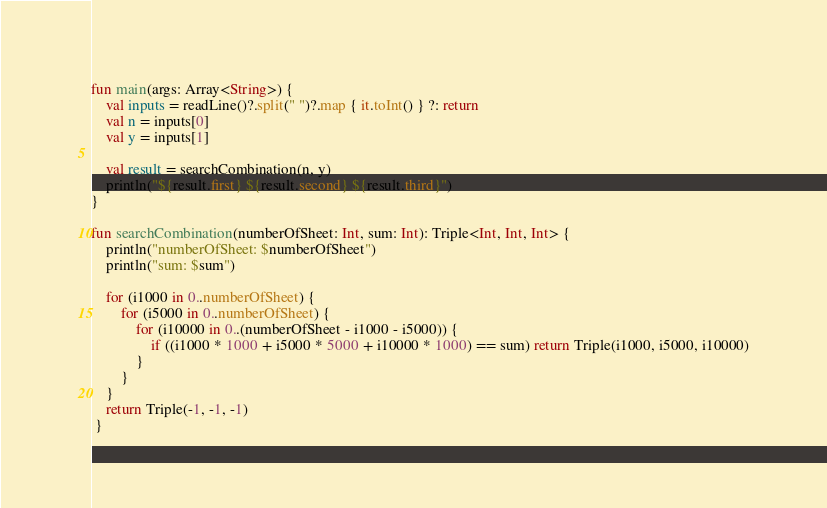Convert code to text. <code><loc_0><loc_0><loc_500><loc_500><_Kotlin_>fun main(args: Array<String>) {
    val inputs = readLine()?.split(" ")?.map { it.toInt() } ?: return
    val n = inputs[0]
    val y = inputs[1]

    val result = searchCombination(n, y)
    println("${result.first} ${result.second} ${result.third}")
}

fun searchCombination(numberOfSheet: Int, sum: Int): Triple<Int, Int, Int> {
    println("numberOfSheet: $numberOfSheet")
    println("sum: $sum")

    for (i1000 in 0..numberOfSheet) {
        for (i5000 in 0..numberOfSheet) {
            for (i10000 in 0..(numberOfSheet - i1000 - i5000)) {
                if ((i1000 * 1000 + i5000 * 5000 + i10000 * 1000) == sum) return Triple(i1000, i5000, i10000)
            }
        }
    }
    return Triple(-1, -1, -1)
 }
</code> 